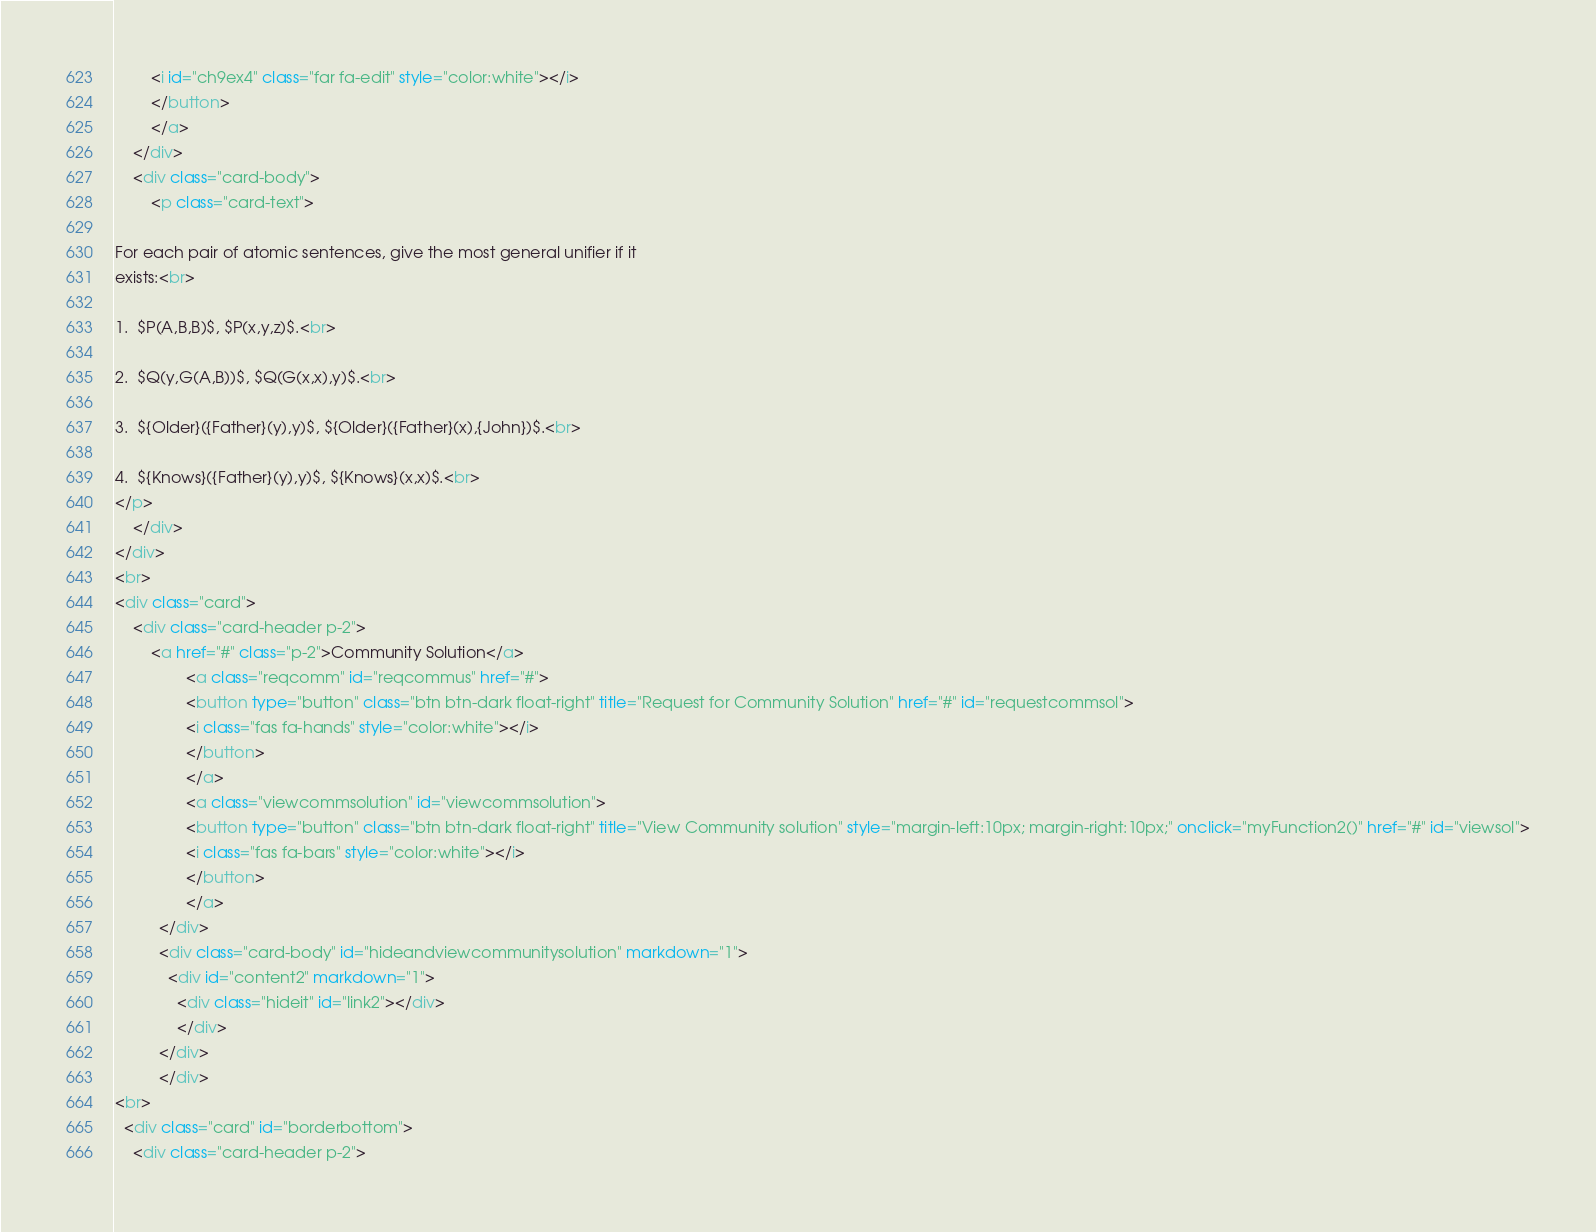<code> <loc_0><loc_0><loc_500><loc_500><_HTML_>        <i id="ch9ex4" class="far fa-edit" style="color:white"></i>
        </button>
        </a>
    </div>
    <div class="card-body">
        <p class="card-text">

For each pair of atomic sentences, give the most general unifier if it
exists:<br>

1.  $P(A,B,B)$, $P(x,y,z)$.<br>

2.  $Q(y,G(A,B))$, $Q(G(x,x),y)$.<br>

3.  ${Older}({Father}(y),y)$, ${Older}({Father}(x),{John})$.<br>

4.  ${Knows}({Father}(y),y)$, ${Knows}(x,x)$.<br>
</p>
    </div>
</div>
<br>
<div class="card">
    <div class="card-header p-2">
        <a href="#" class="p-2">Community Solution</a>
                <a class="reqcomm" id="reqcommus" href="#">
                <button type="button" class="btn btn-dark float-right" title="Request for Community Solution" href="#" id="requestcommsol">
                <i class="fas fa-hands" style="color:white"></i>
                </button>
                </a>
                <a class="viewcommsolution" id="viewcommsolution">
                <button type="button" class="btn btn-dark float-right" title="View Community solution" style="margin-left:10px; margin-right:10px;" onclick="myFunction2()" href="#" id="viewsol">
                <i class="fas fa-bars" style="color:white"></i>
                </button>
                </a>
          </div>
          <div class="card-body" id="hideandviewcommunitysolution" markdown="1">
            <div id="content2" markdown="1">
              <div class="hideit" id="link2"></div>
              </div>
          </div>
          </div>
<br>
  <div class="card" id="borderbottom">
    <div class="card-header p-2"></code> 